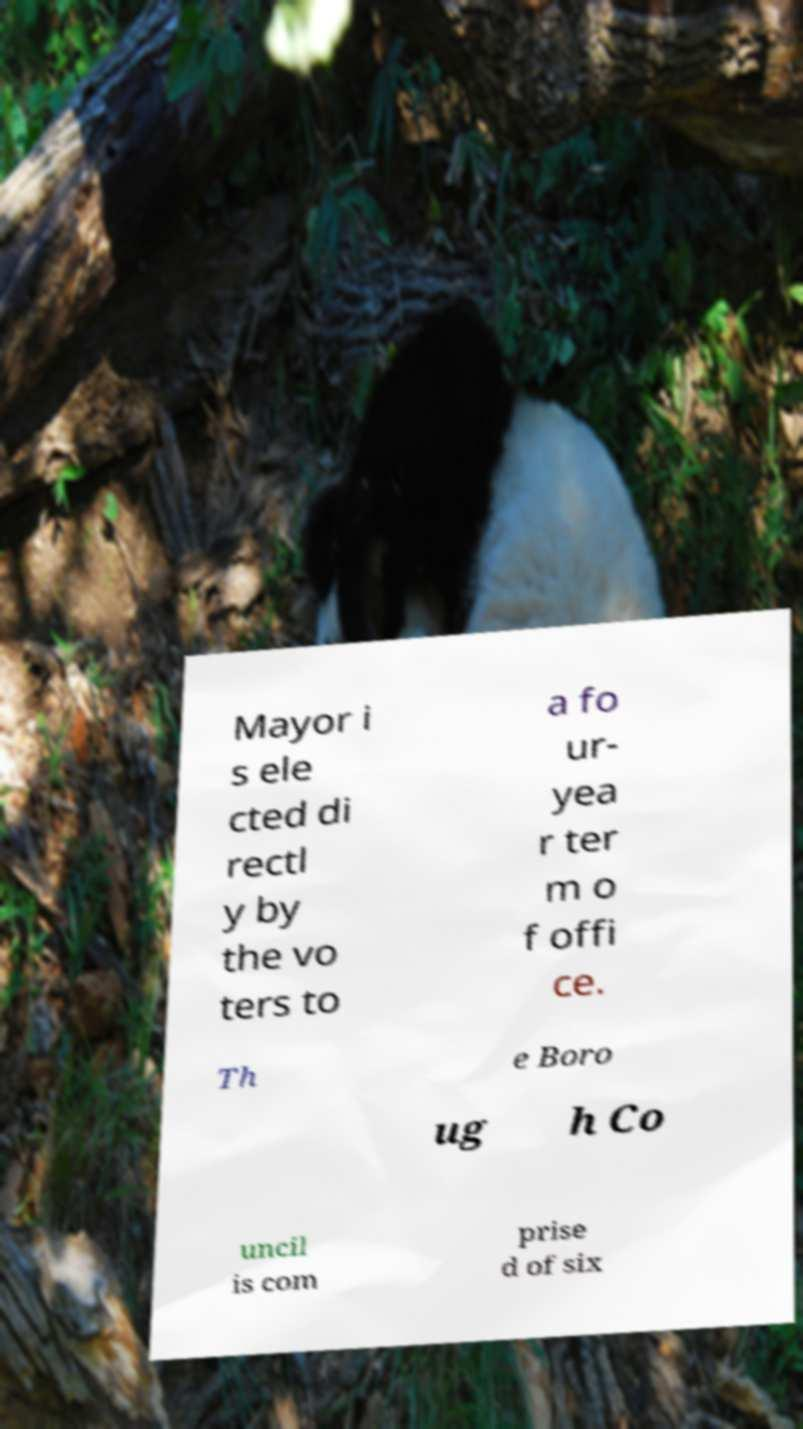Could you assist in decoding the text presented in this image and type it out clearly? Mayor i s ele cted di rectl y by the vo ters to a fo ur- yea r ter m o f offi ce. Th e Boro ug h Co uncil is com prise d of six 